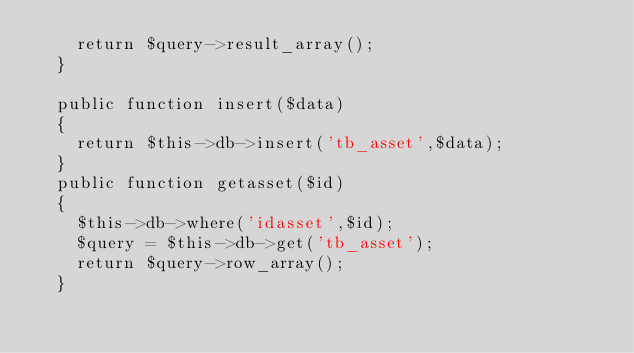<code> <loc_0><loc_0><loc_500><loc_500><_PHP_>		return $query->result_array();
	}

	public function insert($data)
	{
		return $this->db->insert('tb_asset',$data);
	}
	public function getasset($id)
	{
		$this->db->where('idasset',$id);
		$query = $this->db->get('tb_asset');
		return $query->row_array();
	}</code> 